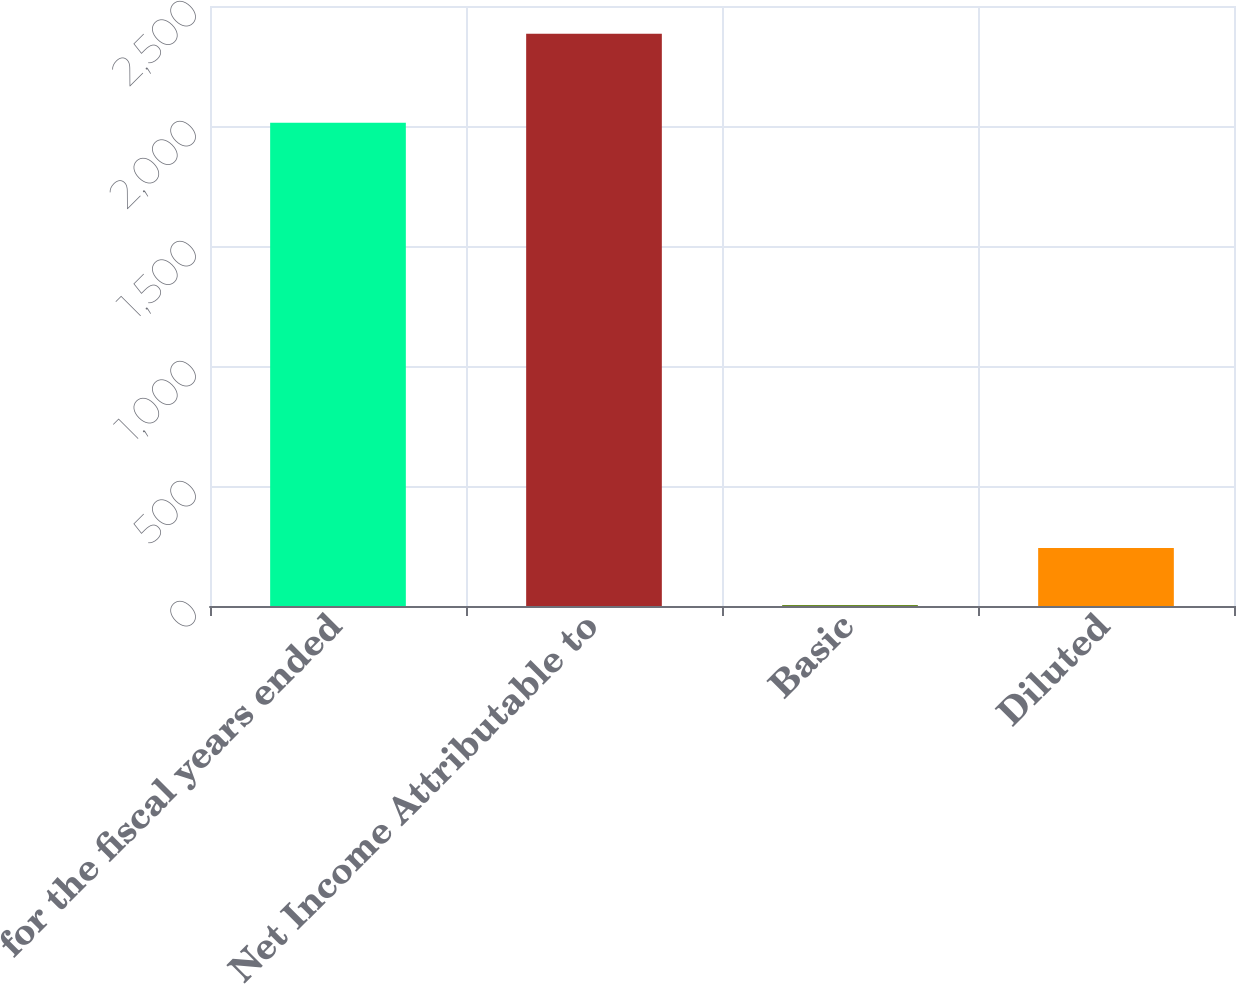<chart> <loc_0><loc_0><loc_500><loc_500><bar_chart><fcel>for the fiscal years ended<fcel>Net Income Attributable to<fcel>Basic<fcel>Diluted<nl><fcel>2014<fcel>2384.3<fcel>3.79<fcel>241.84<nl></chart> 